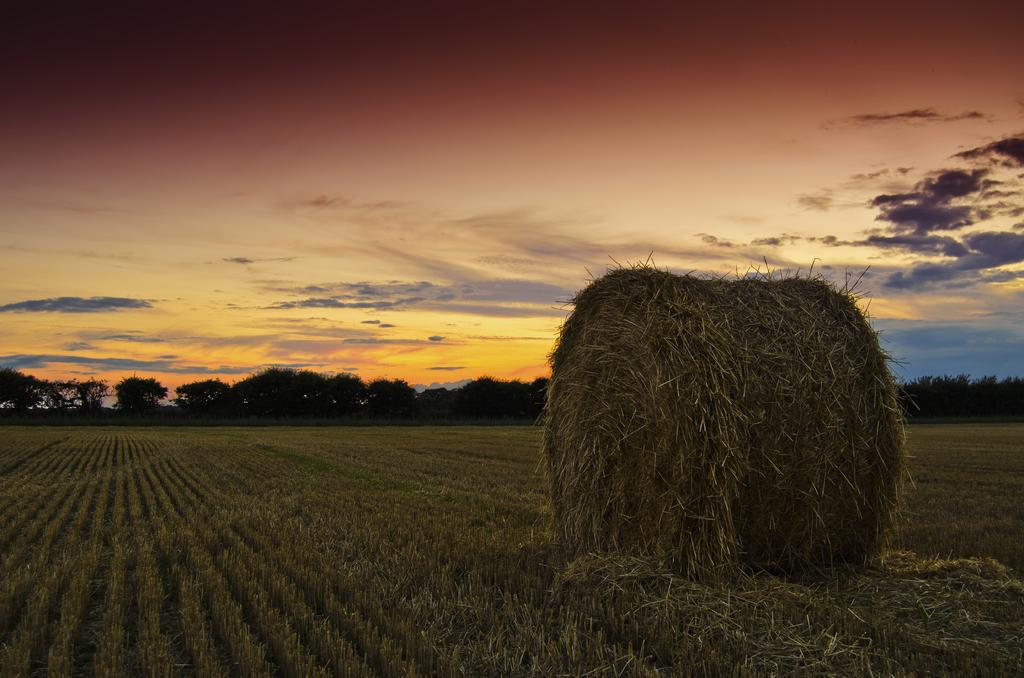What can be seen at the top of the image? The sky is visible towards the top of the image. What is present in the sky? There are clouds in the sky. What type of vegetation is in the image? There are trees in the image. What is present at the bottom of the image? There is grass towards the bottom of the image. What else can be found in the image? There is hay in the image. Can you tell me how many houses are visible in the image? There are no houses present in the image. What type of calculator is being used in the image? There is no calculator present in the image. 